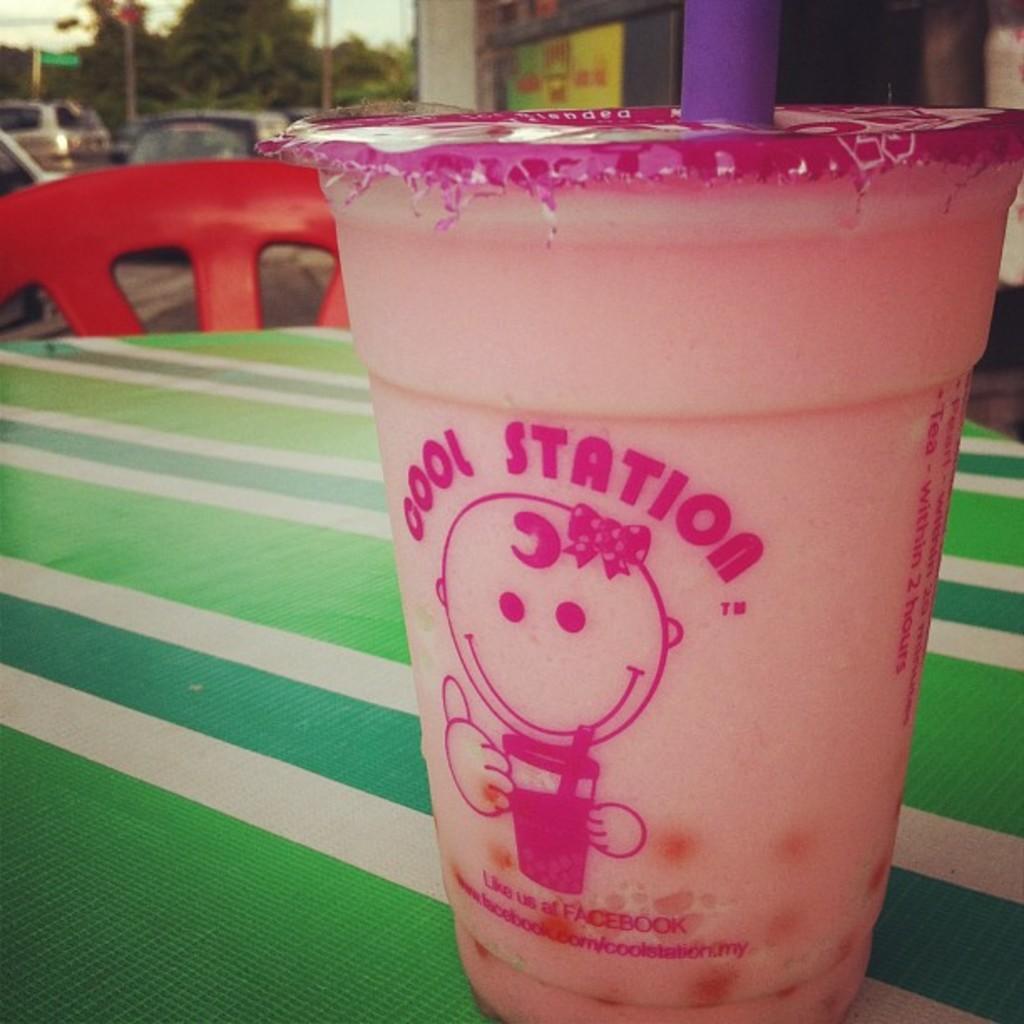Can you describe this image briefly? In this image there is a coffee cup on the table behind that there are some cars and building. 